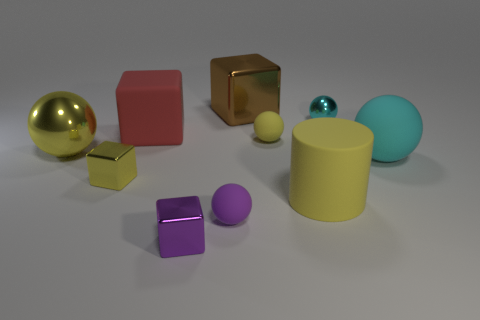Are there any large yellow metal objects of the same shape as the brown object?
Your response must be concise. No. There is another shiny block that is the same size as the purple cube; what is its color?
Give a very brief answer. Yellow. Are there fewer big cyan matte things on the left side of the small yellow matte sphere than small blocks that are behind the small cyan sphere?
Provide a short and direct response. No. There is a metal sphere that is in front of the cyan shiny object; does it have the same size as the tiny purple shiny block?
Provide a succinct answer. No. There is a yellow metallic object that is behind the yellow metallic cube; what shape is it?
Make the answer very short. Sphere. Is the number of matte cylinders greater than the number of big green things?
Your response must be concise. Yes. Does the big cube that is on the left side of the purple metal thing have the same color as the large cylinder?
Offer a terse response. No. What number of objects are big red cubes that are on the right side of the small yellow shiny thing or metallic things in front of the big brown thing?
Your answer should be very brief. 5. What number of shiny things are in front of the brown metallic thing and to the left of the large cylinder?
Keep it short and to the point. 3. Do the large yellow cylinder and the brown block have the same material?
Ensure brevity in your answer.  No. 